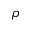Convert formula to latex. <formula><loc_0><loc_0><loc_500><loc_500>\rho</formula> 